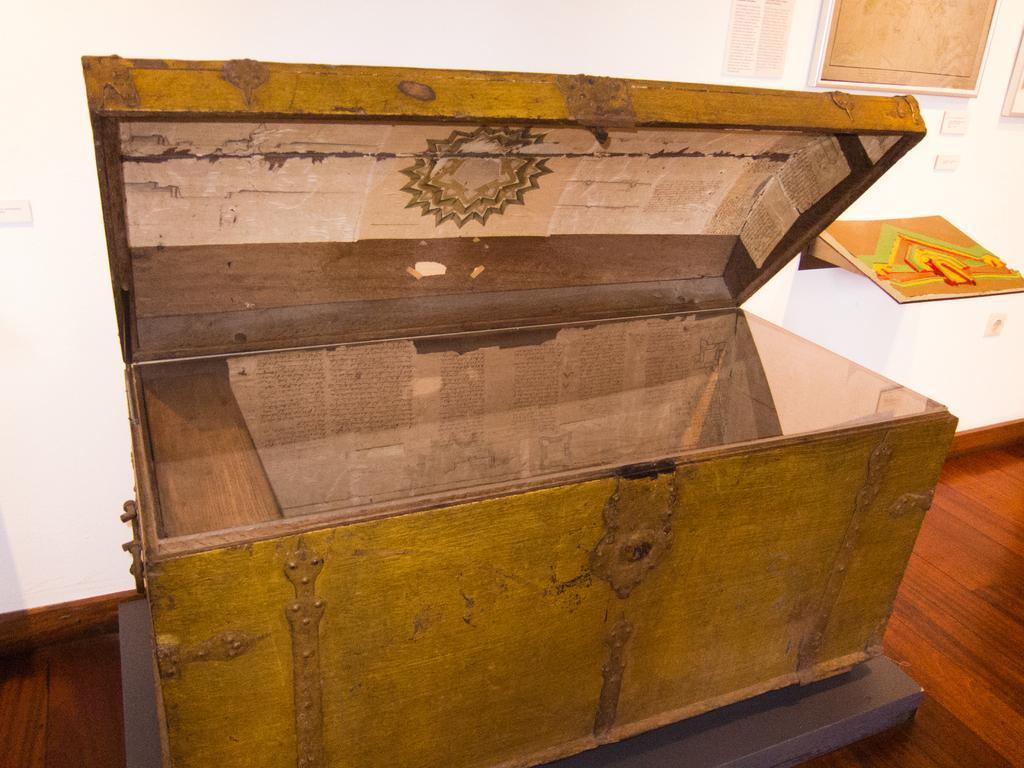How would you summarize this image in a sentence or two? In the center of the image we can see a box placed on the surface. On the right side of the image we can see some photo frames on the wall and a poster with some text. 